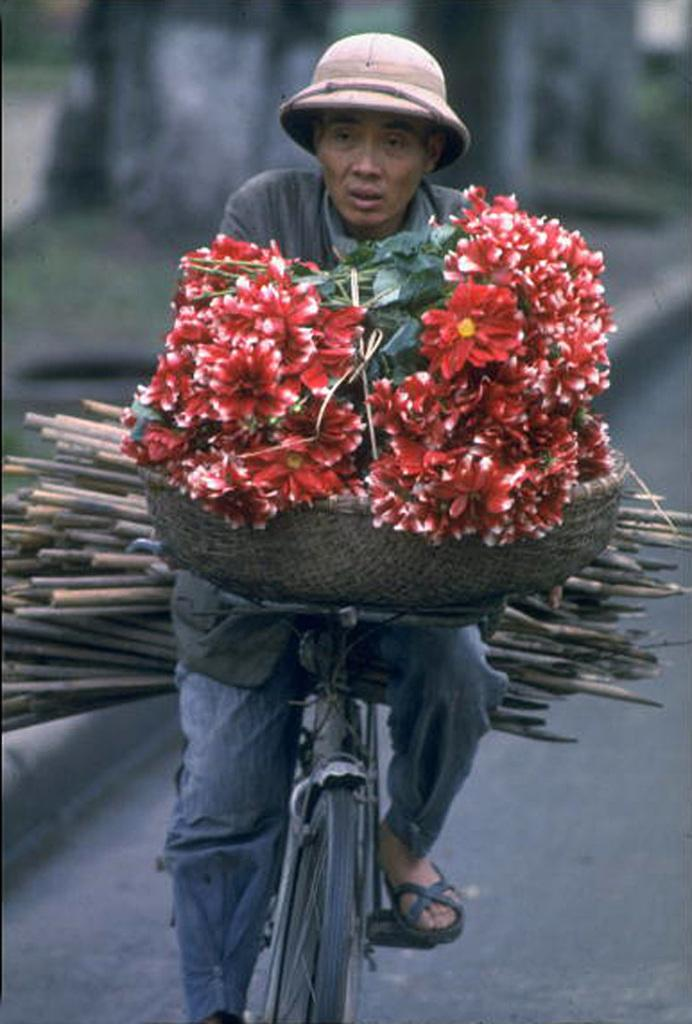What is the main subject of the image? The main subject of the image is a person riding a bicycle. What can be seen in the basket on the front of the bicycle? There are flowers in a basket on the front of the bicycle. What is the person wearing on their head? The person is wearing a cap. What type of shade is provided by the bucket in the image? There is no bucket present in the image, so no shade is provided by a bucket. 